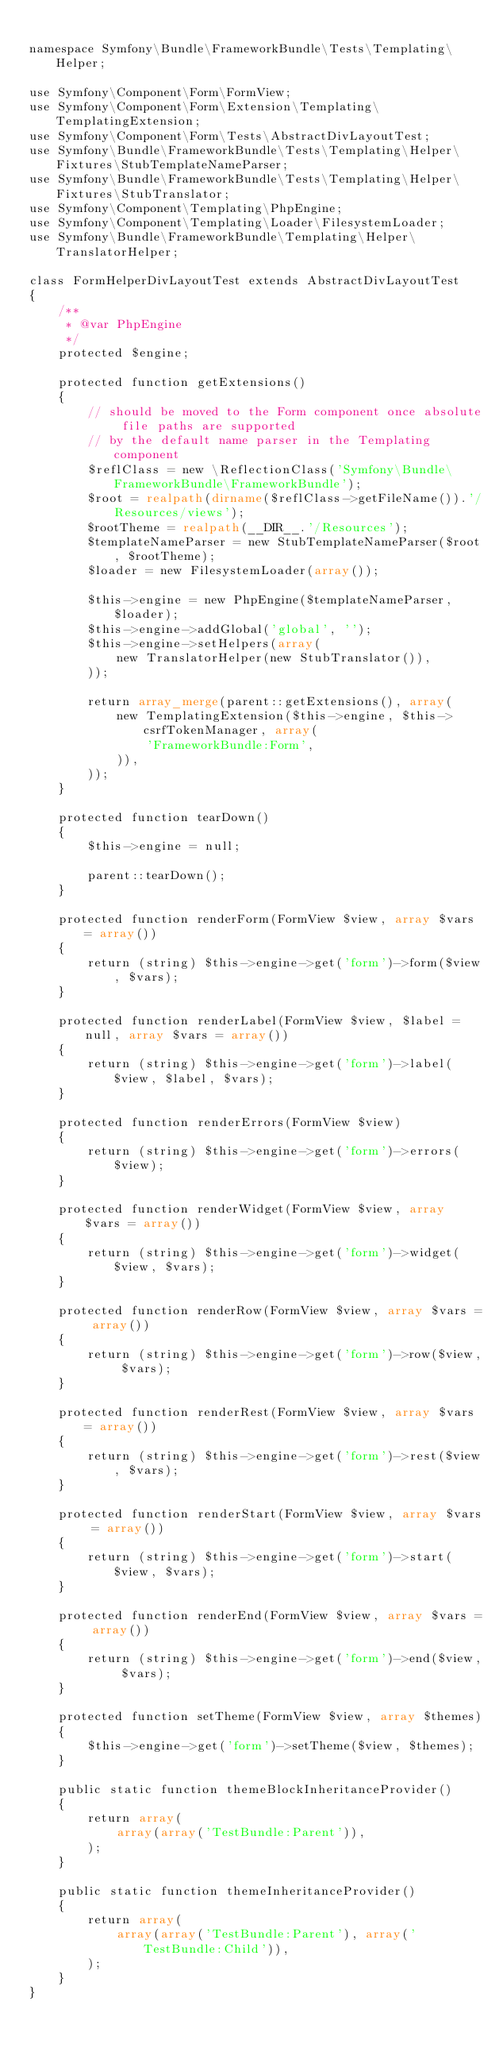Convert code to text. <code><loc_0><loc_0><loc_500><loc_500><_PHP_>
namespace Symfony\Bundle\FrameworkBundle\Tests\Templating\Helper;

use Symfony\Component\Form\FormView;
use Symfony\Component\Form\Extension\Templating\TemplatingExtension;
use Symfony\Component\Form\Tests\AbstractDivLayoutTest;
use Symfony\Bundle\FrameworkBundle\Tests\Templating\Helper\Fixtures\StubTemplateNameParser;
use Symfony\Bundle\FrameworkBundle\Tests\Templating\Helper\Fixtures\StubTranslator;
use Symfony\Component\Templating\PhpEngine;
use Symfony\Component\Templating\Loader\FilesystemLoader;
use Symfony\Bundle\FrameworkBundle\Templating\Helper\TranslatorHelper;

class FormHelperDivLayoutTest extends AbstractDivLayoutTest
{
    /**
     * @var PhpEngine
     */
    protected $engine;

    protected function getExtensions()
    {
        // should be moved to the Form component once absolute file paths are supported
        // by the default name parser in the Templating component
        $reflClass = new \ReflectionClass('Symfony\Bundle\FrameworkBundle\FrameworkBundle');
        $root = realpath(dirname($reflClass->getFileName()).'/Resources/views');
        $rootTheme = realpath(__DIR__.'/Resources');
        $templateNameParser = new StubTemplateNameParser($root, $rootTheme);
        $loader = new FilesystemLoader(array());

        $this->engine = new PhpEngine($templateNameParser, $loader);
        $this->engine->addGlobal('global', '');
        $this->engine->setHelpers(array(
            new TranslatorHelper(new StubTranslator()),
        ));

        return array_merge(parent::getExtensions(), array(
            new TemplatingExtension($this->engine, $this->csrfTokenManager, array(
                'FrameworkBundle:Form',
            )),
        ));
    }

    protected function tearDown()
    {
        $this->engine = null;

        parent::tearDown();
    }

    protected function renderForm(FormView $view, array $vars = array())
    {
        return (string) $this->engine->get('form')->form($view, $vars);
    }

    protected function renderLabel(FormView $view, $label = null, array $vars = array())
    {
        return (string) $this->engine->get('form')->label($view, $label, $vars);
    }

    protected function renderErrors(FormView $view)
    {
        return (string) $this->engine->get('form')->errors($view);
    }

    protected function renderWidget(FormView $view, array $vars = array())
    {
        return (string) $this->engine->get('form')->widget($view, $vars);
    }

    protected function renderRow(FormView $view, array $vars = array())
    {
        return (string) $this->engine->get('form')->row($view, $vars);
    }

    protected function renderRest(FormView $view, array $vars = array())
    {
        return (string) $this->engine->get('form')->rest($view, $vars);
    }

    protected function renderStart(FormView $view, array $vars = array())
    {
        return (string) $this->engine->get('form')->start($view, $vars);
    }

    protected function renderEnd(FormView $view, array $vars = array())
    {
        return (string) $this->engine->get('form')->end($view, $vars);
    }

    protected function setTheme(FormView $view, array $themes)
    {
        $this->engine->get('form')->setTheme($view, $themes);
    }

    public static function themeBlockInheritanceProvider()
    {
        return array(
            array(array('TestBundle:Parent')),
        );
    }

    public static function themeInheritanceProvider()
    {
        return array(
            array(array('TestBundle:Parent'), array('TestBundle:Child')),
        );
    }
}
</code> 